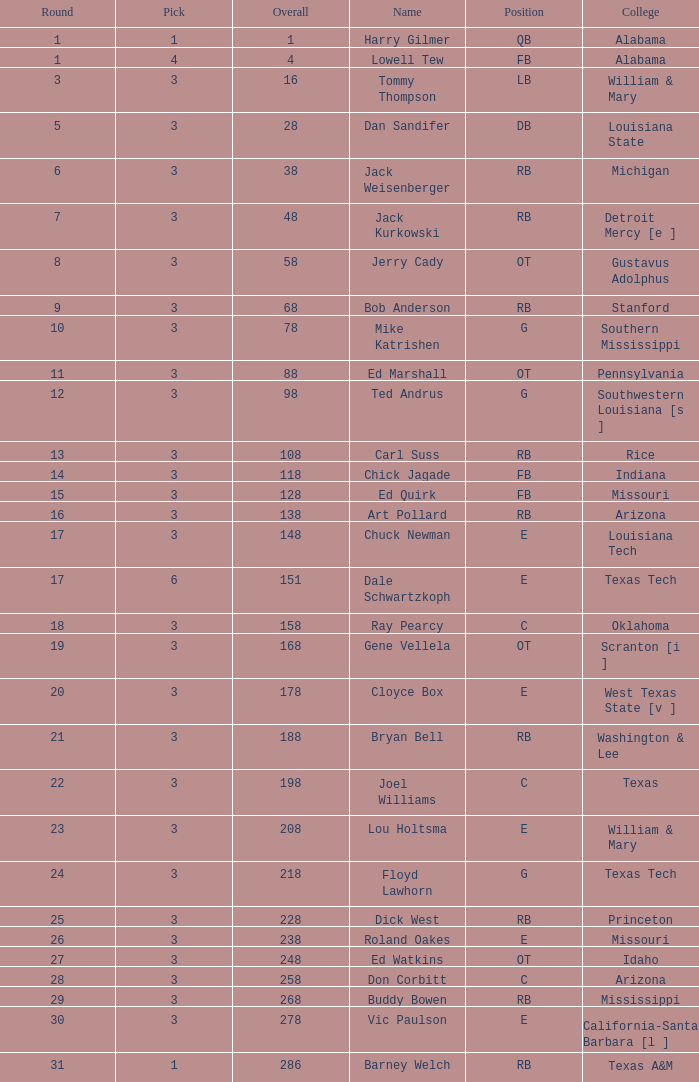What is the average aggregate for stanford? 68.0. 